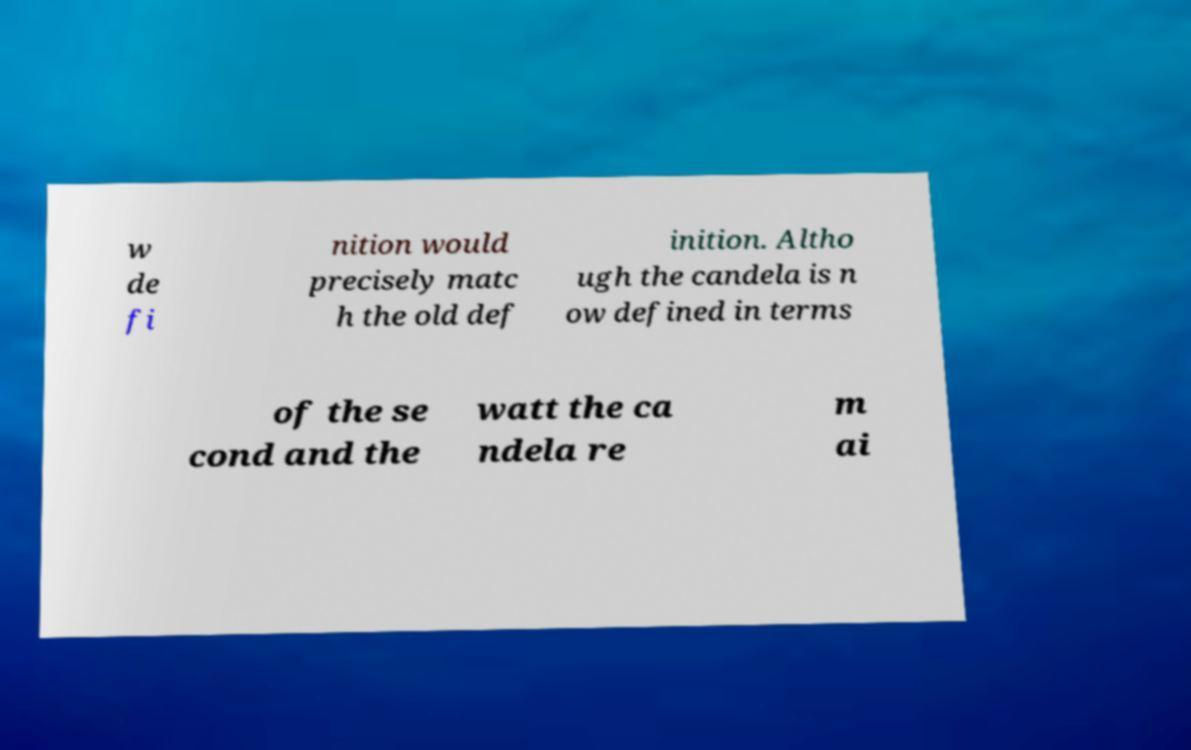Could you extract and type out the text from this image? w de fi nition would precisely matc h the old def inition. Altho ugh the candela is n ow defined in terms of the se cond and the watt the ca ndela re m ai 